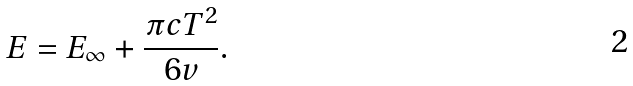<formula> <loc_0><loc_0><loc_500><loc_500>E = E _ { \infty } + \frac { \pi c T ^ { 2 } } { 6 v } .</formula> 